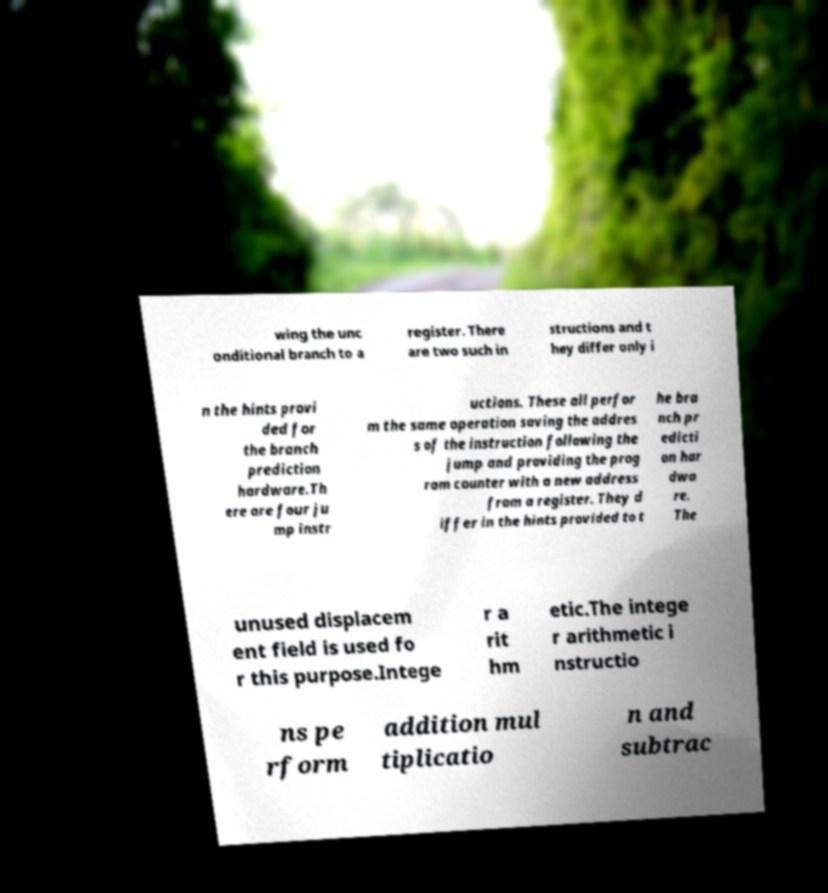Please identify and transcribe the text found in this image. wing the unc onditional branch to a register. There are two such in structions and t hey differ only i n the hints provi ded for the branch prediction hardware.Th ere are four ju mp instr uctions. These all perfor m the same operation saving the addres s of the instruction following the jump and providing the prog ram counter with a new address from a register. They d iffer in the hints provided to t he bra nch pr edicti on har dwa re. The unused displacem ent field is used fo r this purpose.Intege r a rit hm etic.The intege r arithmetic i nstructio ns pe rform addition mul tiplicatio n and subtrac 